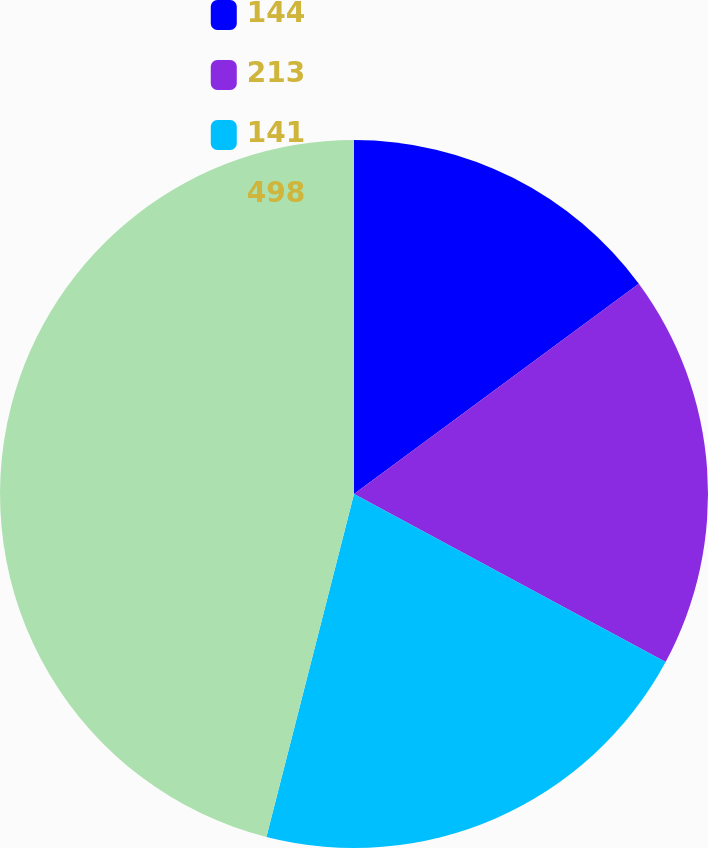Convert chart to OTSL. <chart><loc_0><loc_0><loc_500><loc_500><pie_chart><fcel>144<fcel>213<fcel>141<fcel>498<nl><fcel>14.88%<fcel>17.99%<fcel>21.11%<fcel>46.02%<nl></chart> 